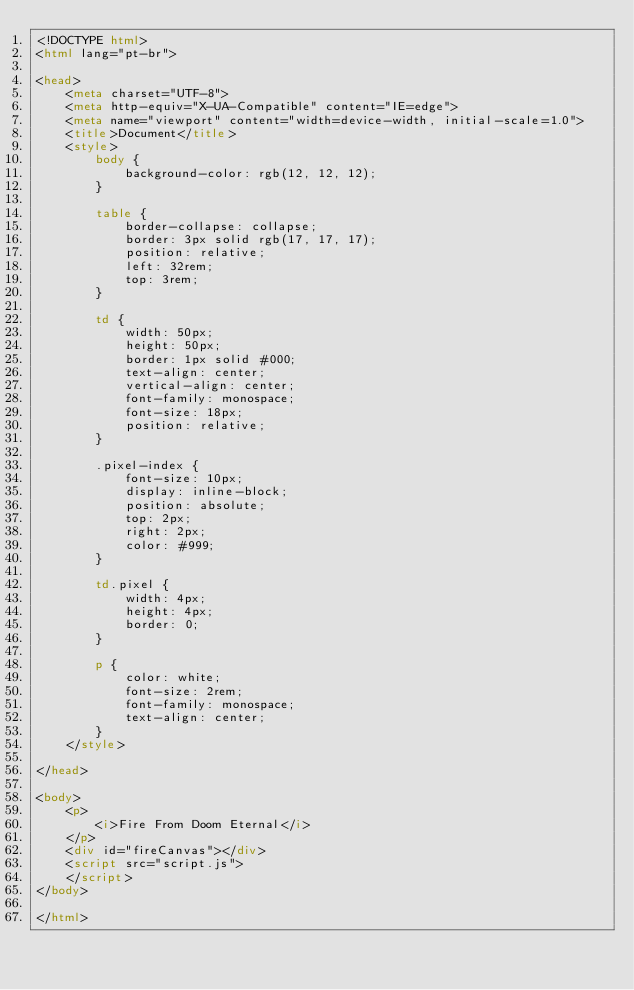<code> <loc_0><loc_0><loc_500><loc_500><_HTML_><!DOCTYPE html>
<html lang="pt-br">

<head>
    <meta charset="UTF-8">
    <meta http-equiv="X-UA-Compatible" content="IE=edge">
    <meta name="viewport" content="width=device-width, initial-scale=1.0">
    <title>Document</title>
    <style>
        body {
            background-color: rgb(12, 12, 12);
        }
        
        table {
            border-collapse: collapse;
            border: 3px solid rgb(17, 17, 17);
            position: relative;
            left: 32rem;
            top: 3rem;
        }
        
        td {
            width: 50px;
            height: 50px;
            border: 1px solid #000;
            text-align: center;
            vertical-align: center;
            font-family: monospace;
            font-size: 18px;
            position: relative;
        }
        
        .pixel-index {
            font-size: 10px;
            display: inline-block;
            position: absolute;
            top: 2px;
            right: 2px;
            color: #999;
        }
        
        td.pixel {
            width: 4px;
            height: 4px;
            border: 0;
        }
        
        p {
            color: white;
            font-size: 2rem;
            font-family: monospace;
            text-align: center;
        }
    </style>

</head>

<body>
    <p>
        <i>Fire From Doom Eternal</i>
    </p>
    <div id="fireCanvas"></div>
    <script src="script.js">
    </script>
</body>

</html></code> 